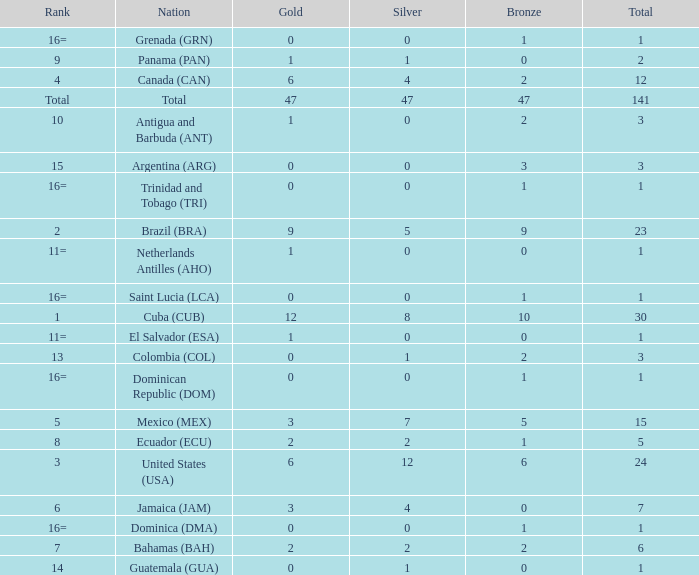How many bronzes have a Nation of jamaica (jam), and a Total smaller than 7? 0.0. 